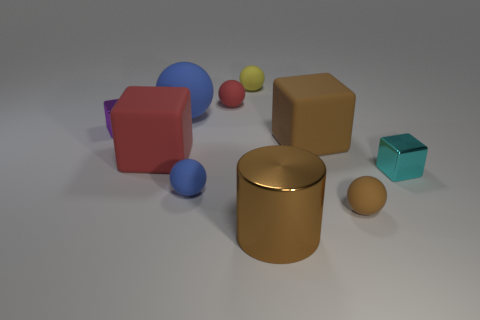Subtract 2 spheres. How many spheres are left? 3 Subtract all brown balls. How many balls are left? 4 Subtract all small brown rubber balls. How many balls are left? 4 Subtract all blue blocks. Subtract all red balls. How many blocks are left? 4 Subtract all cubes. How many objects are left? 6 Add 4 green metallic cylinders. How many green metallic cylinders exist? 4 Subtract 1 cyan blocks. How many objects are left? 9 Subtract all tiny metallic cylinders. Subtract all tiny cyan blocks. How many objects are left? 9 Add 5 small cyan things. How many small cyan things are left? 6 